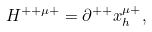<formula> <loc_0><loc_0><loc_500><loc_500>H ^ { + + \mu + } = \partial ^ { + + } x ^ { \mu + } _ { h } ,</formula> 